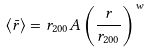Convert formula to latex. <formula><loc_0><loc_0><loc_500><loc_500>\langle \bar { r } \rangle = r _ { 2 0 0 } A \left ( \frac { r } { r _ { 2 0 0 } } \right ) ^ { w }</formula> 